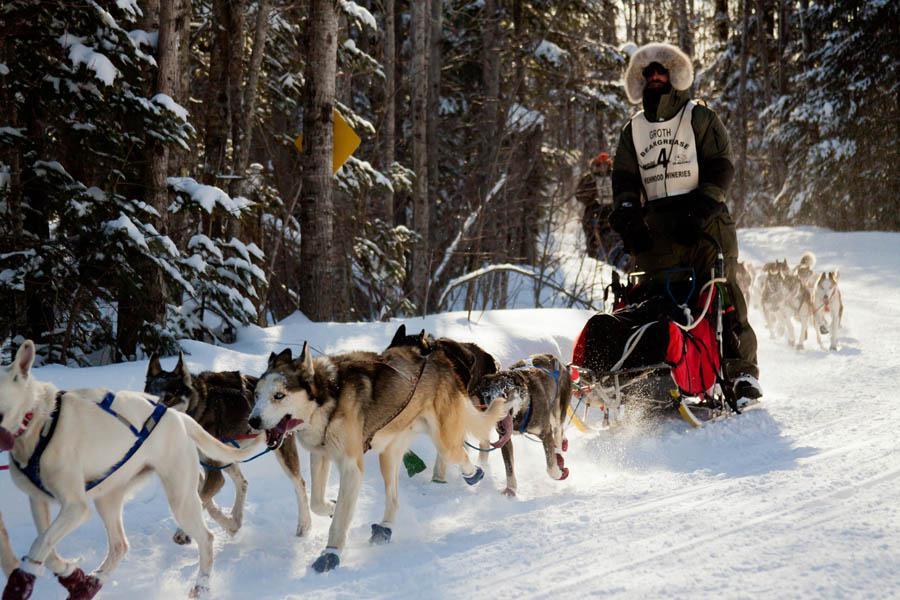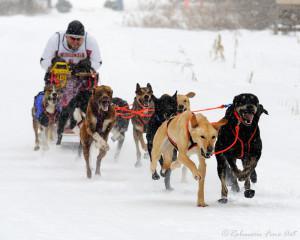The first image is the image on the left, the second image is the image on the right. Analyze the images presented: Is the assertion "In one image a team of sled dogs are pulling a person to the left." valid? Answer yes or no. Yes. The first image is the image on the left, the second image is the image on the right. Given the left and right images, does the statement "At least one of the teams is exactly six dogs." hold true? Answer yes or no. No. 